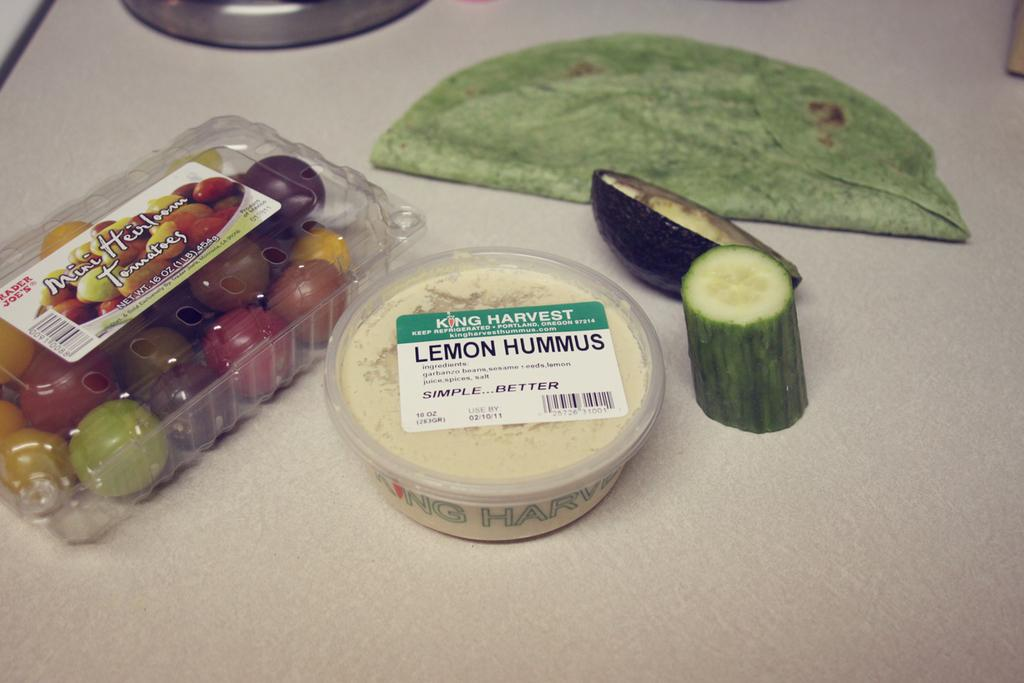What type of table is in the image? There is a white table in the image. What vegetables are present on the table? Cucumber and brinjal are present on the table. What type of food is present on the table? Paratha is present on the table. What dairy product is present on the table? There is a box containing cream on the table. What type of sweet treat is present on the table? There is a plastic box containing different color chocolates on the table. Where is the nearest park to the table in the image? The image does not provide information about the location of a park, so it cannot be determined from the image. 